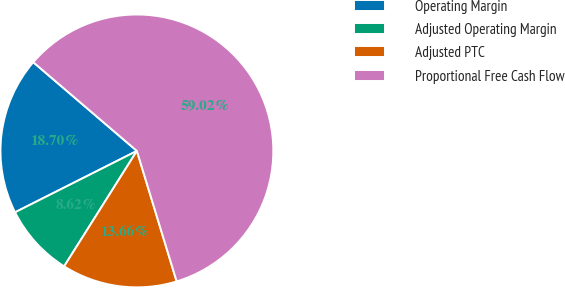Convert chart to OTSL. <chart><loc_0><loc_0><loc_500><loc_500><pie_chart><fcel>Operating Margin<fcel>Adjusted Operating Margin<fcel>Adjusted PTC<fcel>Proportional Free Cash Flow<nl><fcel>18.7%<fcel>8.62%<fcel>13.66%<fcel>59.02%<nl></chart> 